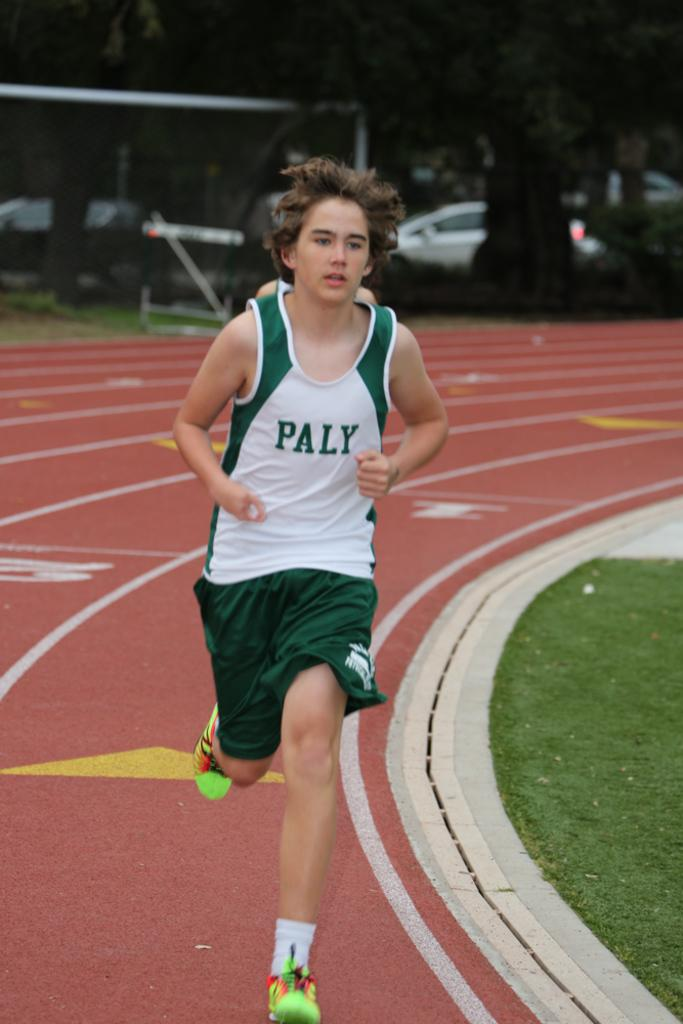<image>
Share a concise interpretation of the image provided. A track runner has on a PALY uniform. 